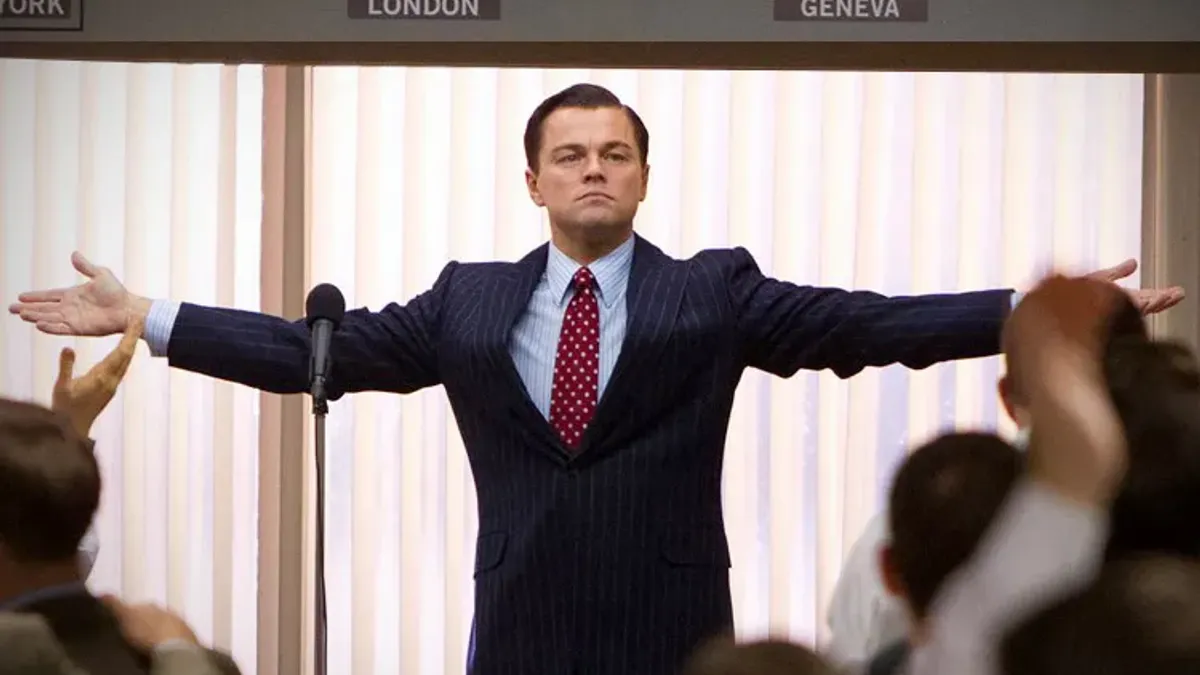Hi I'm a blind user and I hope to understand an image that my friend showed me about a movie she watched last night. Could you please teach me what this scene is about? I really appreciate your help! The image is from the movie "The Wolf of Wall Street". It shows Leonardo DiCaprio, who plays the character of Jordan Belfort, standing in front of a group of people. His arms are outstretched, as if he is embracing them. 

Jordan Belfort is a stockbroker who was convicted of fraud. In this scene, he is giving a motivational speech to his employees, encouraging them to be ambitious and to make money, regardless of the consequences.  He is promoting a lifestyle of greed and excess, which he himself ultimately embraced and was destroyed by. 

This image is a powerful reminder of the dangers of unchecked ambition and the seductive allure of wealth, even when it is obtained through unethical means. 